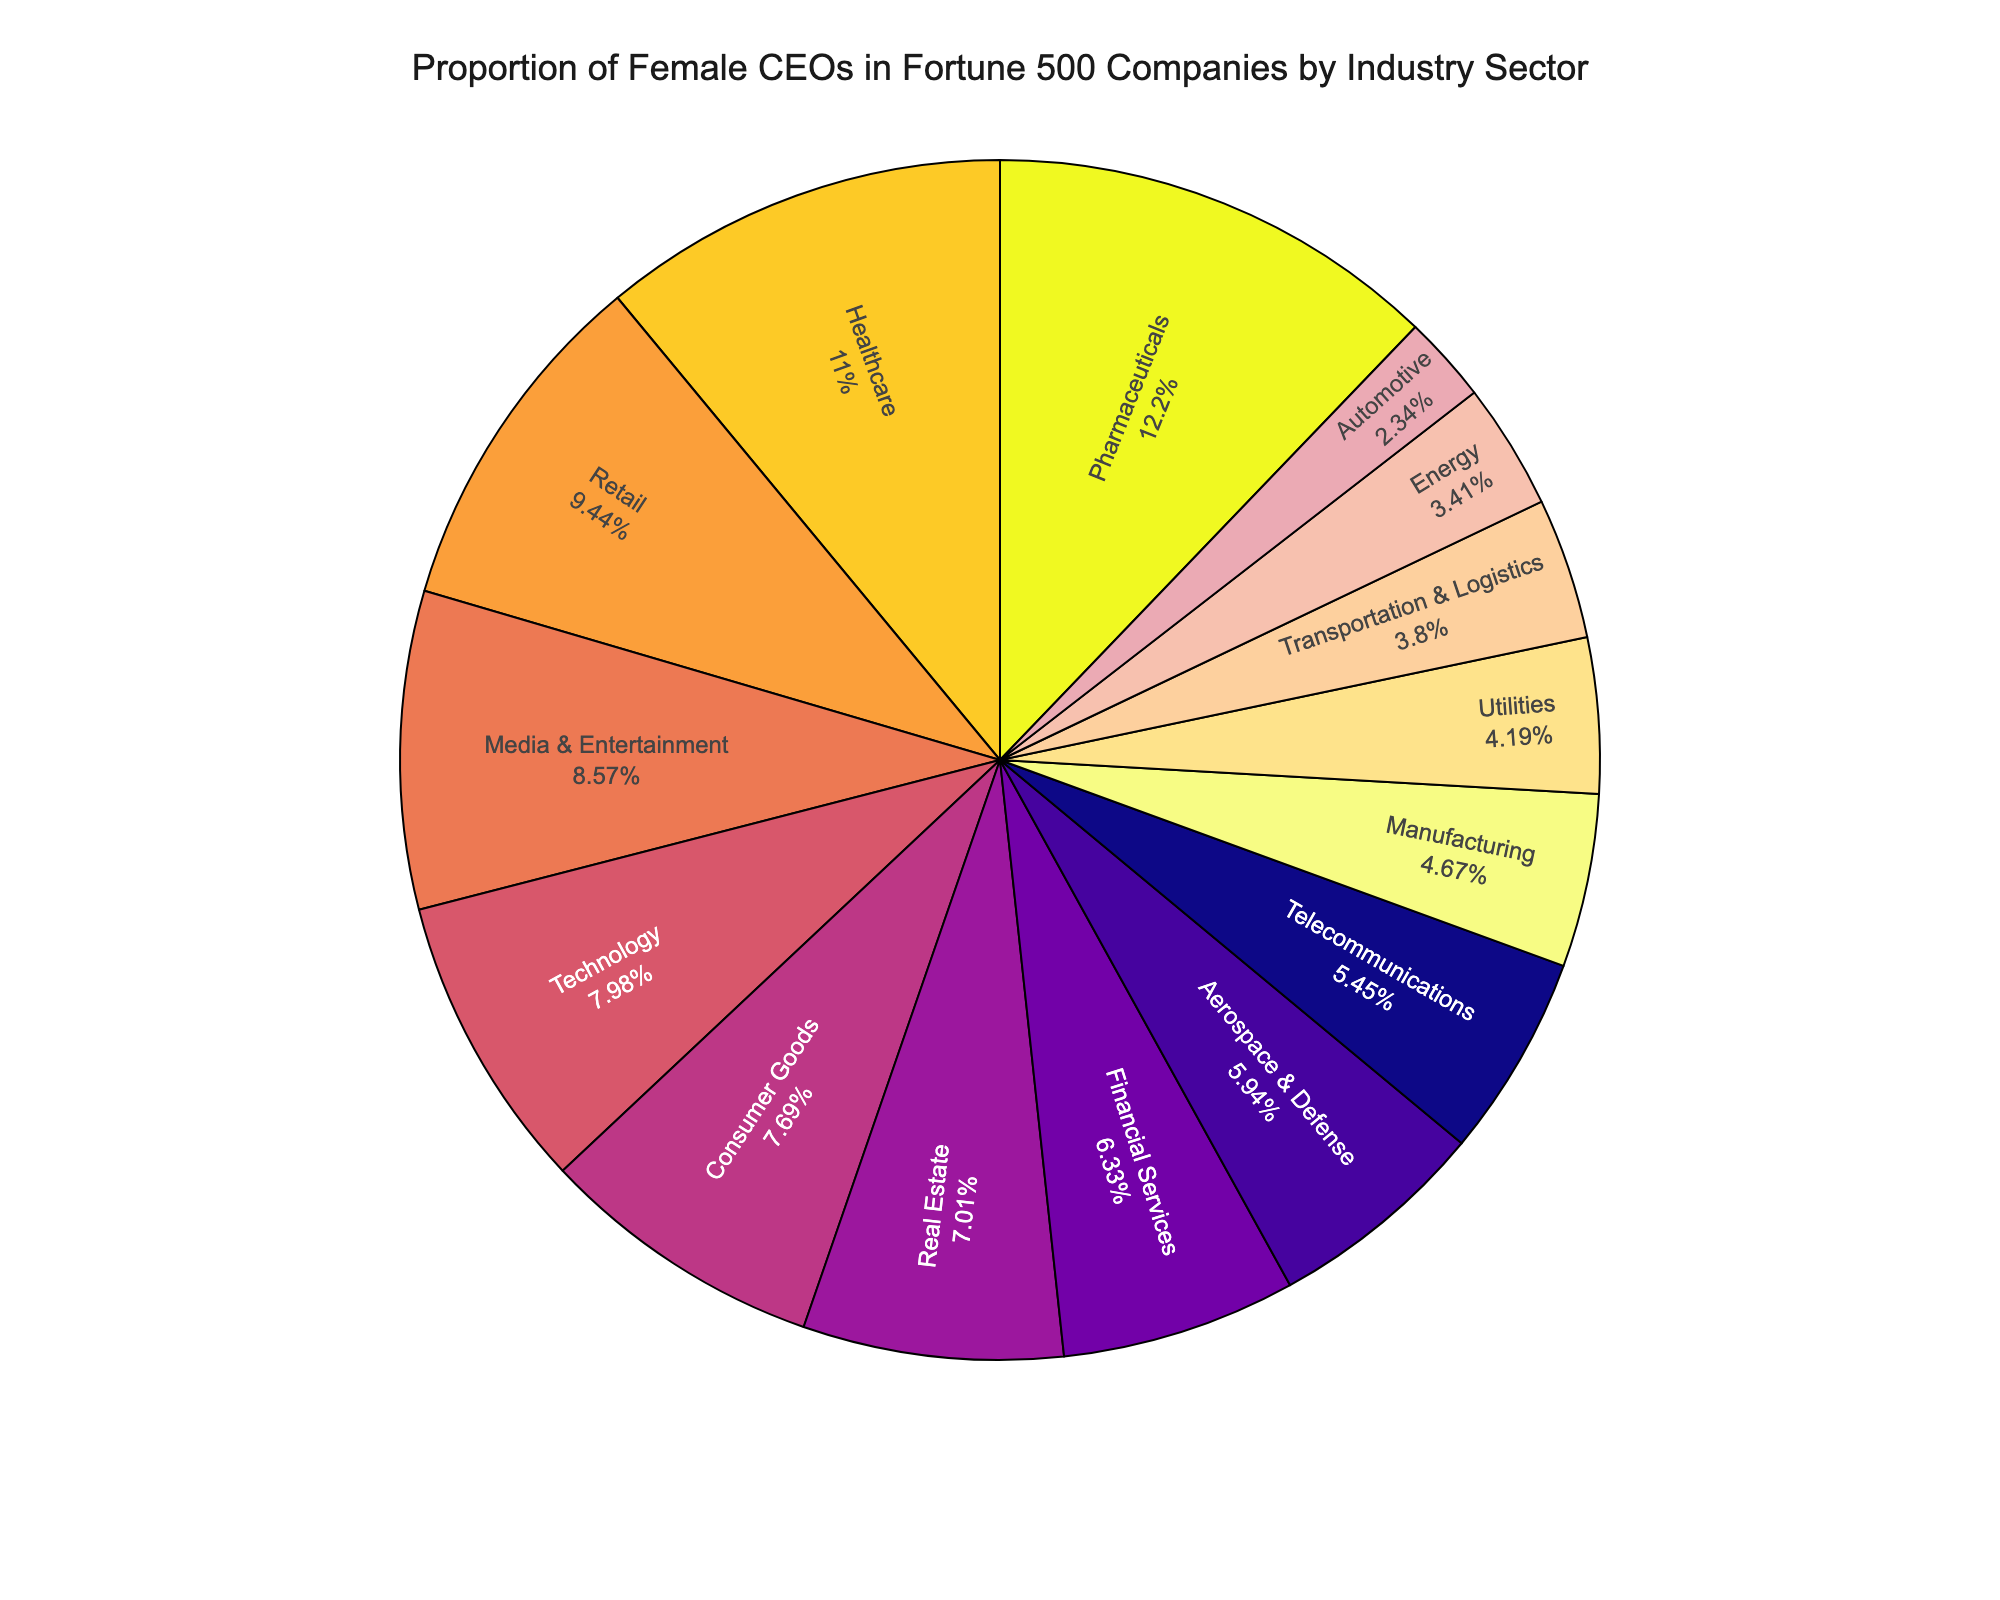What is the industry sector with the highest proportion of female CEOs? The sector with the highest percentage of female CEOs can be identified by looking for the largest slice in the pie chart.
Answer: Pharmaceuticals Which sector has a lower proportion of female CEOs, Energy or Technology? Compare the slices representing Energy and Technology. Energy has a smaller slice than Technology, indicating a lower proportion of female CEOs.
Answer: Energy What is the combined percentage of female CEOs in Manufacturing, Energy, and Utilities sectors? Sum the percentages of female CEOs in Manufacturing (4.8%), Energy (3.5%), and Utilities (4.3%). The combined percentage is 4.8 + 3.5 + 4.3 = 12.6%.
Answer: 12.6% Are there more female CEOs in Healthcare or Automotive sector? Compare the slices representing Healthcare and Automotive. Healthcare's slice is larger than Automotive's, indicating a higher proportion of female CEOs in Healthcare.
Answer: Healthcare Which three sectors have the lowest proportion of female CEOs? Identify the three smallest slices in the pie chart and check their corresponding sectors. The smallest slices represent Automotive, Energy, and Transportation & Logistics.
Answer: Automotive, Energy, Transportation & Logistics Compare the proportion of female CEOs in Retail to Real Estate. Which sector is higher and by how much? Compare the slices for Retail and Real Estate. Retail has a larger slice than Real Estate. Subtract the percentage of Real Estate (7.2%) from Retail (9.7%) to find the difference: 9.7 - 7.2 = 2.5%.
Answer: Retail by 2.5% What is the average percentage of female CEOs in Technology, Financial Services, and Media & Entertainment sectors? Calculate the average by summing the percentages for Technology (8.2%), Financial Services (6.5%), and Media & Entertainment (8.8%) and dividing by 3: (8.2 + 6.5 + 8.8) / 3 ≈ 7.83%.
Answer: 7.83% How does the proportion of female CEOs in Telecommunications compare to Aerospace & Defense? Compare the slices representing Telecommunications (5.6%) and Aerospace & Defense (6.1%). Aerospace & Defense's slice is slightly larger.
Answer: Aerospace & Defense Which sector has a proportion of female CEOs closest to 10%? Look for the sector whose slice percentage is closest to 10%. Retail has a proportion of 9.7%, which is closest to 10%.
Answer: Retail 